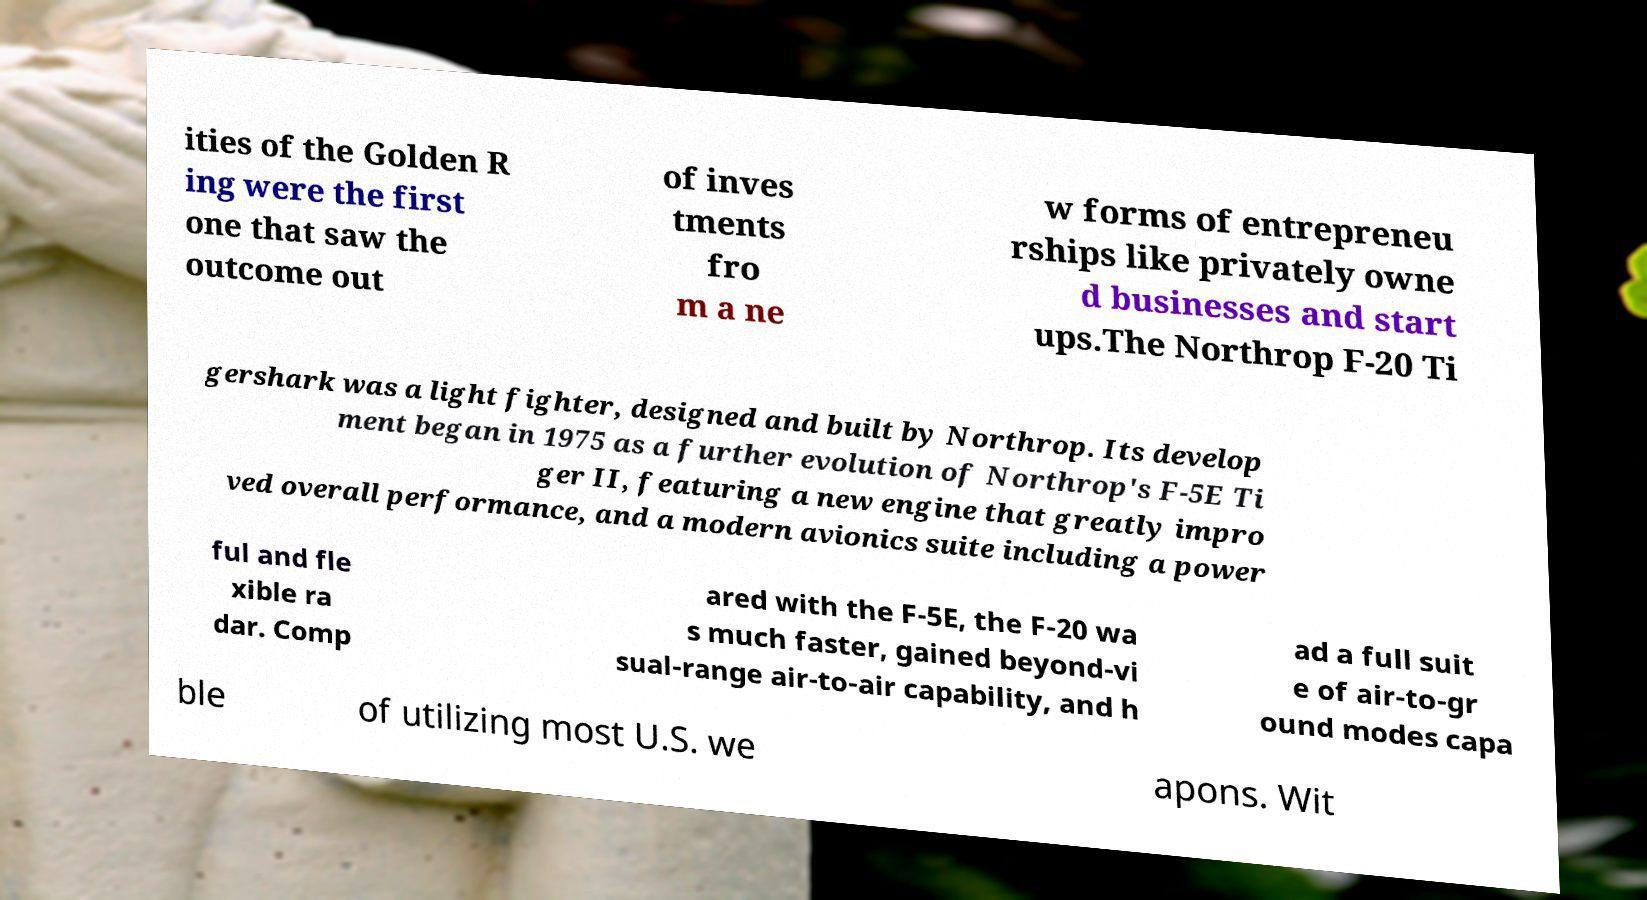Could you extract and type out the text from this image? ities of the Golden R ing were the first one that saw the outcome out of inves tments fro m a ne w forms of entrepreneu rships like privately owne d businesses and start ups.The Northrop F-20 Ti gershark was a light fighter, designed and built by Northrop. Its develop ment began in 1975 as a further evolution of Northrop's F-5E Ti ger II, featuring a new engine that greatly impro ved overall performance, and a modern avionics suite including a power ful and fle xible ra dar. Comp ared with the F-5E, the F-20 wa s much faster, gained beyond-vi sual-range air-to-air capability, and h ad a full suit e of air-to-gr ound modes capa ble of utilizing most U.S. we apons. Wit 